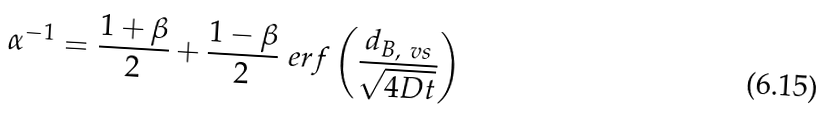Convert formula to latex. <formula><loc_0><loc_0><loc_500><loc_500>\alpha ^ { - 1 } = \frac { 1 + \beta } 2 + \frac { 1 - \beta } 2 \ e r f \left ( \frac { d _ { B , \ v s } } { \sqrt { 4 D t } } \right )</formula> 